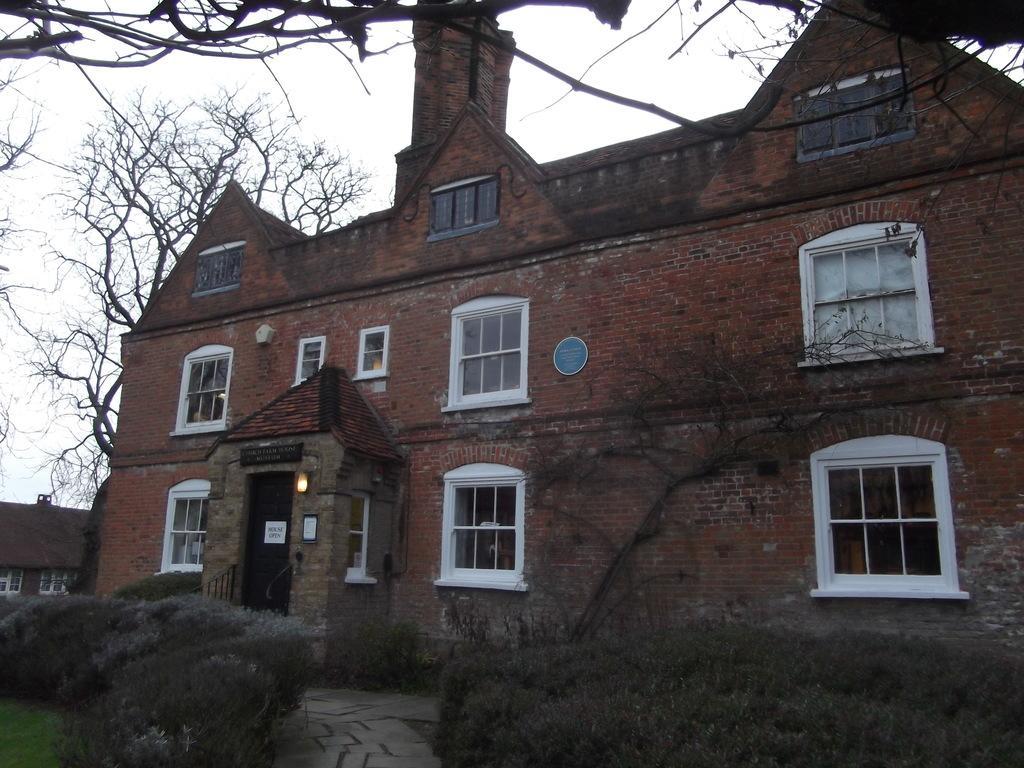Describe this image in one or two sentences. In this picture I can see there is a building here and there is a walk way here and in the backdrop I can see there are trees and the sky is clear. 